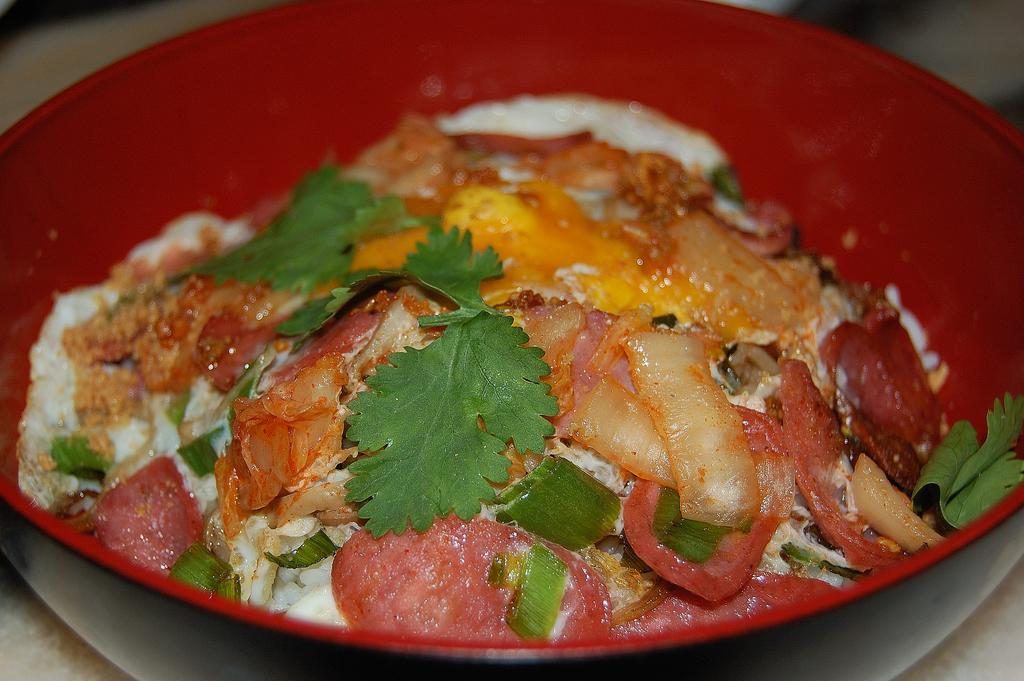What is present on the plate in the image? There is a bowl on the plate in the image. What is inside the bowl on the plate? There is food in the bowl on the plate. What type of smoke can be seen coming from the food in the image? There is no smoke present in the image; it only shows a plate with a bowl of food. 